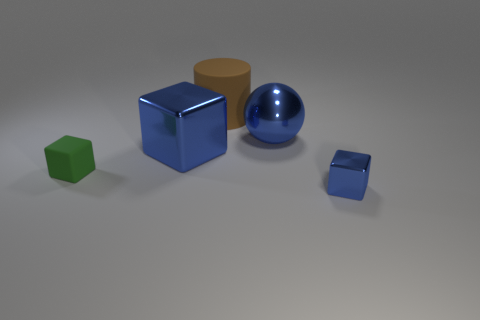The shiny object that is the same size as the blue ball is what color?
Your response must be concise. Blue. Do the brown matte object and the blue ball have the same size?
Provide a short and direct response. Yes. There is a small metal object; how many green cubes are on the right side of it?
Provide a succinct answer. 0. How many objects are blue things that are in front of the tiny green thing or large things?
Provide a short and direct response. 4. Are there more large metallic things that are to the right of the large matte thing than blue cubes that are in front of the green thing?
Offer a very short reply. No. The other metal block that is the same color as the tiny metal cube is what size?
Keep it short and to the point. Large. Is the size of the blue metallic ball the same as the metal object that is on the left side of the large blue ball?
Keep it short and to the point. Yes. What number of cylinders are either big brown objects or blue metallic objects?
Your answer should be very brief. 1. What size is the thing that is made of the same material as the green cube?
Ensure brevity in your answer.  Large. Is the size of the green matte object to the left of the big blue cube the same as the blue cube on the left side of the tiny blue block?
Provide a succinct answer. No. 